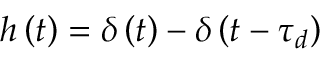Convert formula to latex. <formula><loc_0><loc_0><loc_500><loc_500>h \left ( t \right ) = \delta \left ( t \right ) - \delta \left ( t - \tau _ { d } \right )</formula> 